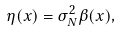<formula> <loc_0><loc_0><loc_500><loc_500>\eta ( { x } ) = \sigma _ { N } ^ { 2 } \beta ( { x } ) ,</formula> 